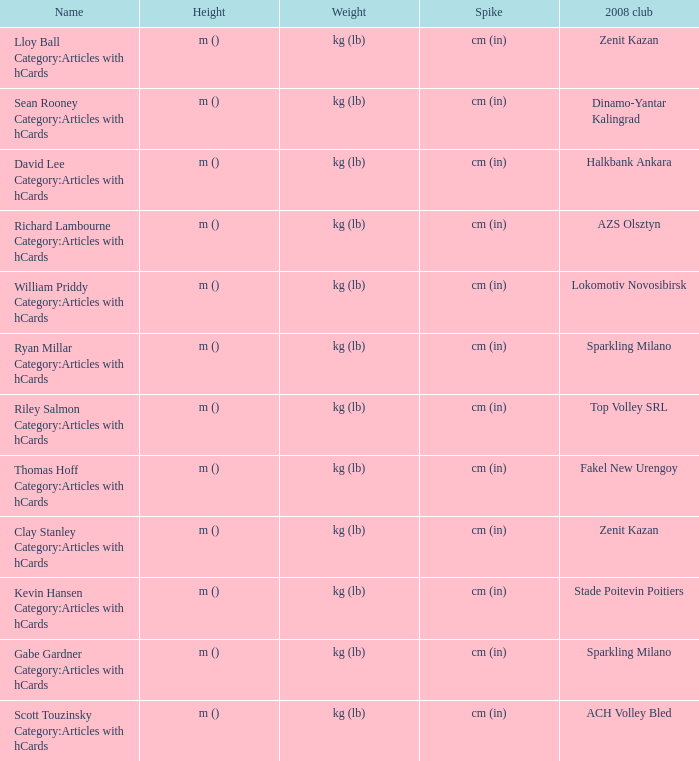What is the name for the 2008 club of Azs olsztyn? Richard Lambourne Category:Articles with hCards. 